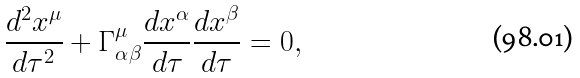<formula> <loc_0><loc_0><loc_500><loc_500>\frac { d ^ { 2 } x ^ { \mu } } { d \tau ^ { 2 } } + \Gamma ^ { \mu } _ { \alpha \beta } \frac { d x ^ { \alpha } } { d \tau } \frac { d x ^ { \beta } } { d \tau } = 0 ,</formula> 